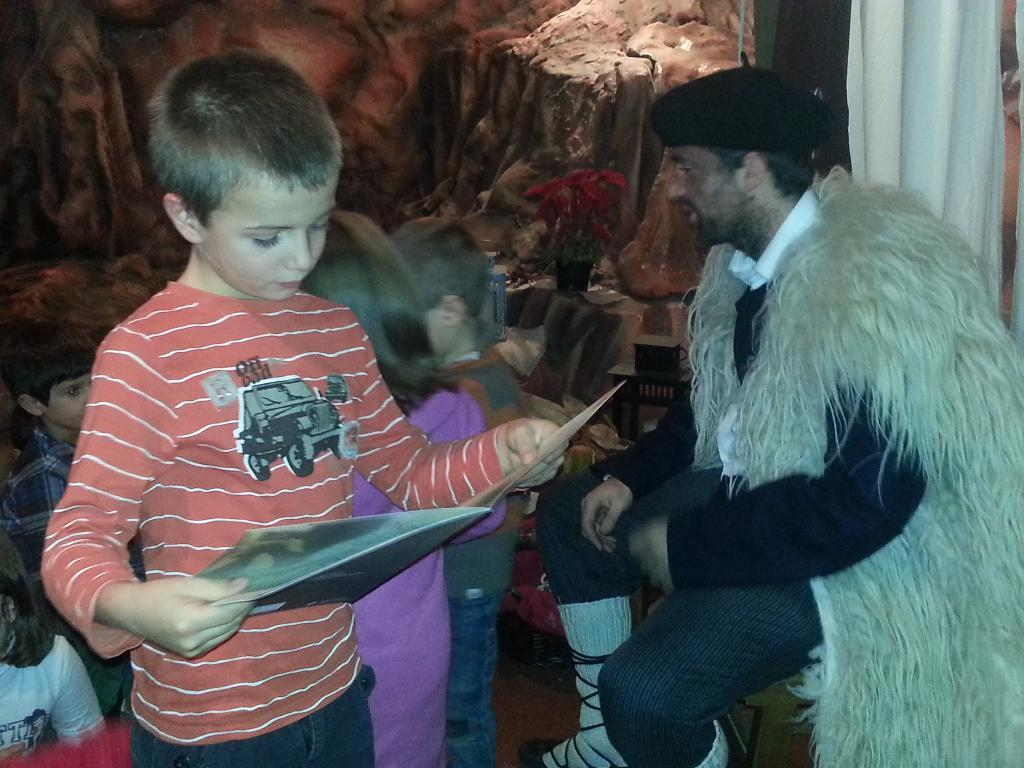How many people are in the image? There is a group of people in the image. What can be observed about the attire of the people in the image? The people are wearing different color dresses. What is one person holding in the image? One person is holding a file. What can be seen in the background of the image? There is a curtain and a rack in the background of the image. What type of cable can be seen connecting the planes in the image? There are no planes present in the image, so there is no cable connecting them. What flavor of jelly is being served to the people in the image? There is no jelly present in the image, so it cannot be determined what flavor might be served. 